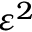Convert formula to latex. <formula><loc_0><loc_0><loc_500><loc_500>\varepsilon ^ { 2 }</formula> 